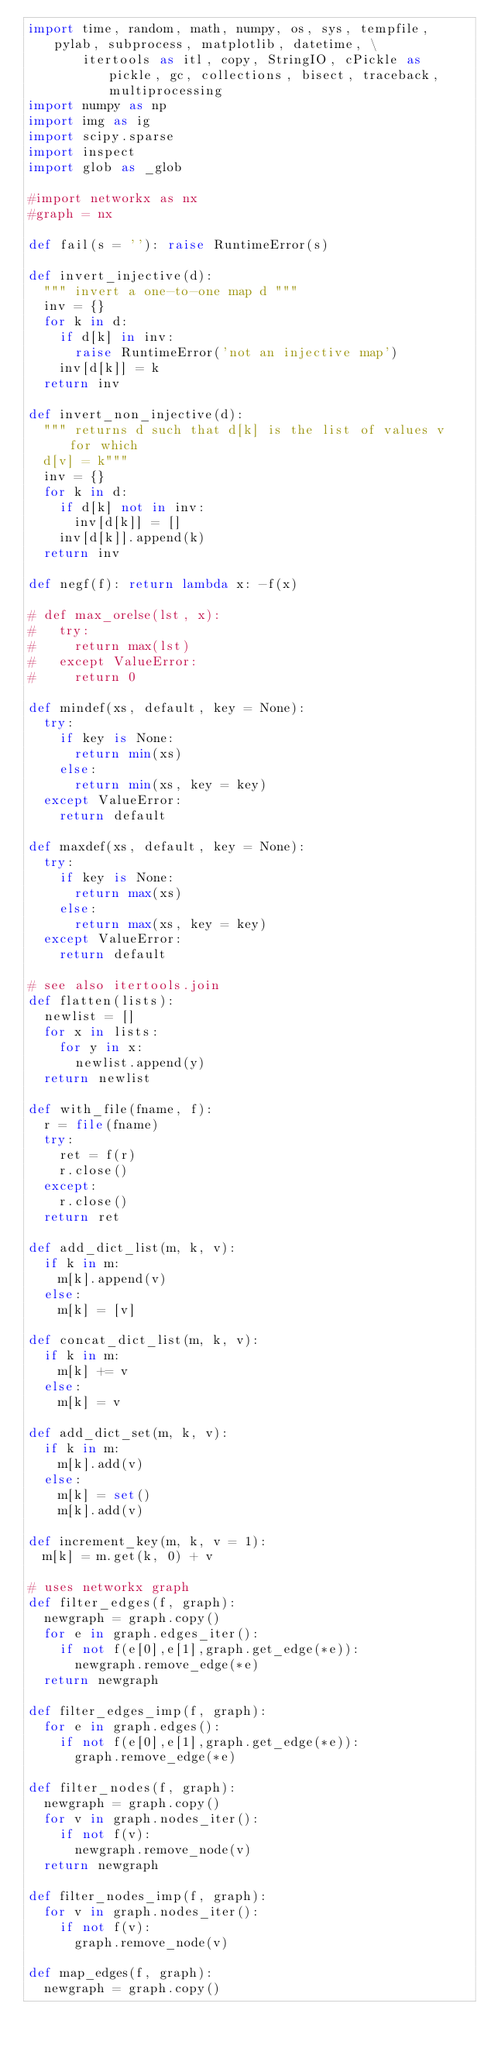Convert code to text. <code><loc_0><loc_0><loc_500><loc_500><_Python_>import time, random, math, numpy, os, sys, tempfile, pylab, subprocess, matplotlib, datetime, \
       itertools as itl, copy, StringIO, cPickle as pickle, gc, collections, bisect, traceback, multiprocessing
import numpy as np
import img as ig
import scipy.sparse
import inspect
import glob as _glob

#import networkx as nx
#graph = nx

def fail(s = ''): raise RuntimeError(s)

def invert_injective(d):
  """ invert a one-to-one map d """
  inv = {}
  for k in d:
    if d[k] in inv:
      raise RuntimeError('not an injective map')
    inv[d[k]] = k
  return inv

def invert_non_injective(d):
  """ returns d such that d[k] is the list of values v for which
  d[v] = k"""
  inv = {}
  for k in d:
    if d[k] not in inv:
      inv[d[k]] = []
    inv[d[k]].append(k)
  return inv

def negf(f): return lambda x: -f(x)

# def max_orelse(lst, x):
#   try:
#     return max(lst)
#   except ValueError:
#     return 0

def mindef(xs, default, key = None):
  try:
    if key is None:
      return min(xs)
    else:
      return min(xs, key = key)
  except ValueError:
    return default

def maxdef(xs, default, key = None):
  try:
    if key is None:
      return max(xs)
    else:
      return max(xs, key = key)
  except ValueError:
    return default

# see also itertools.join
def flatten(lists):
  newlist = []
  for x in lists:
    for y in x:
      newlist.append(y)
  return newlist

def with_file(fname, f):
  r = file(fname)
  try:
    ret = f(r)
    r.close()
  except:
    r.close()
  return ret

def add_dict_list(m, k, v):
  if k in m:
    m[k].append(v)
  else:
    m[k] = [v]

def concat_dict_list(m, k, v):
  if k in m:
    m[k] += v
  else:
    m[k] = v

def add_dict_set(m, k, v):
  if k in m:
    m[k].add(v)
  else:
    m[k] = set()
    m[k].add(v)

def increment_key(m, k, v = 1):
  m[k] = m.get(k, 0) + v
  
# uses networkx graph
def filter_edges(f, graph):
  newgraph = graph.copy()
  for e in graph.edges_iter():
    if not f(e[0],e[1],graph.get_edge(*e)):
      newgraph.remove_edge(*e)
  return newgraph

def filter_edges_imp(f, graph):
  for e in graph.edges():
    if not f(e[0],e[1],graph.get_edge(*e)):
      graph.remove_edge(*e)

def filter_nodes(f, graph):
  newgraph = graph.copy()
  for v in graph.nodes_iter():
    if not f(v):
      newgraph.remove_node(v)
  return newgraph

def filter_nodes_imp(f, graph):
  for v in graph.nodes_iter():
    if not f(v):
      graph.remove_node(v)

def map_edges(f, graph):
  newgraph = graph.copy()</code> 